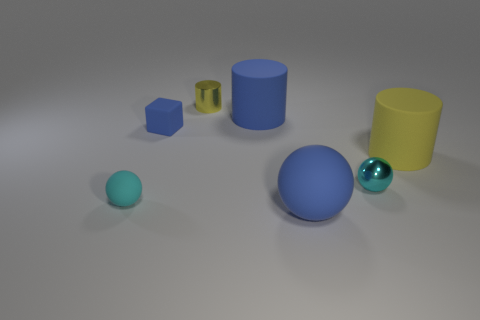Subtract 1 cylinders. How many cylinders are left? 2 Add 2 yellow metallic things. How many objects exist? 9 Subtract all tiny cyan balls. How many balls are left? 1 Subtract all balls. How many objects are left? 4 Add 3 small cyan balls. How many small cyan balls exist? 5 Subtract 1 blue cubes. How many objects are left? 6 Subtract all big brown metallic balls. Subtract all cyan objects. How many objects are left? 5 Add 2 tiny cyan objects. How many tiny cyan objects are left? 4 